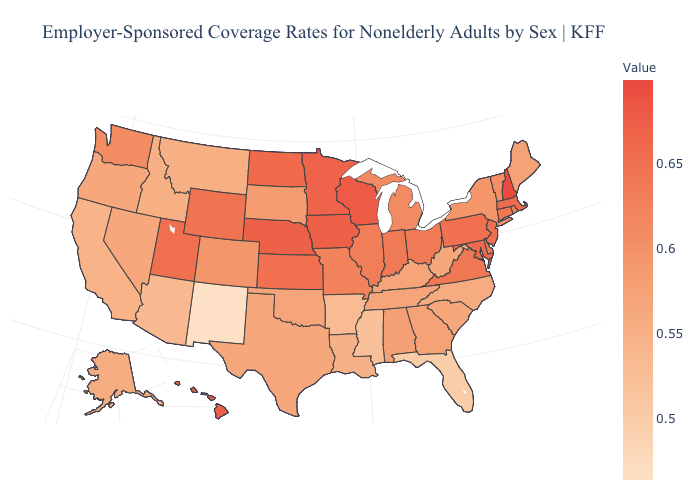Does South Dakota have the lowest value in the MidWest?
Be succinct. Yes. Does Kansas have the lowest value in the USA?
Quick response, please. No. Among the states that border Tennessee , which have the lowest value?
Write a very short answer. Mississippi. Does Arizona have a lower value than Florida?
Be succinct. No. 